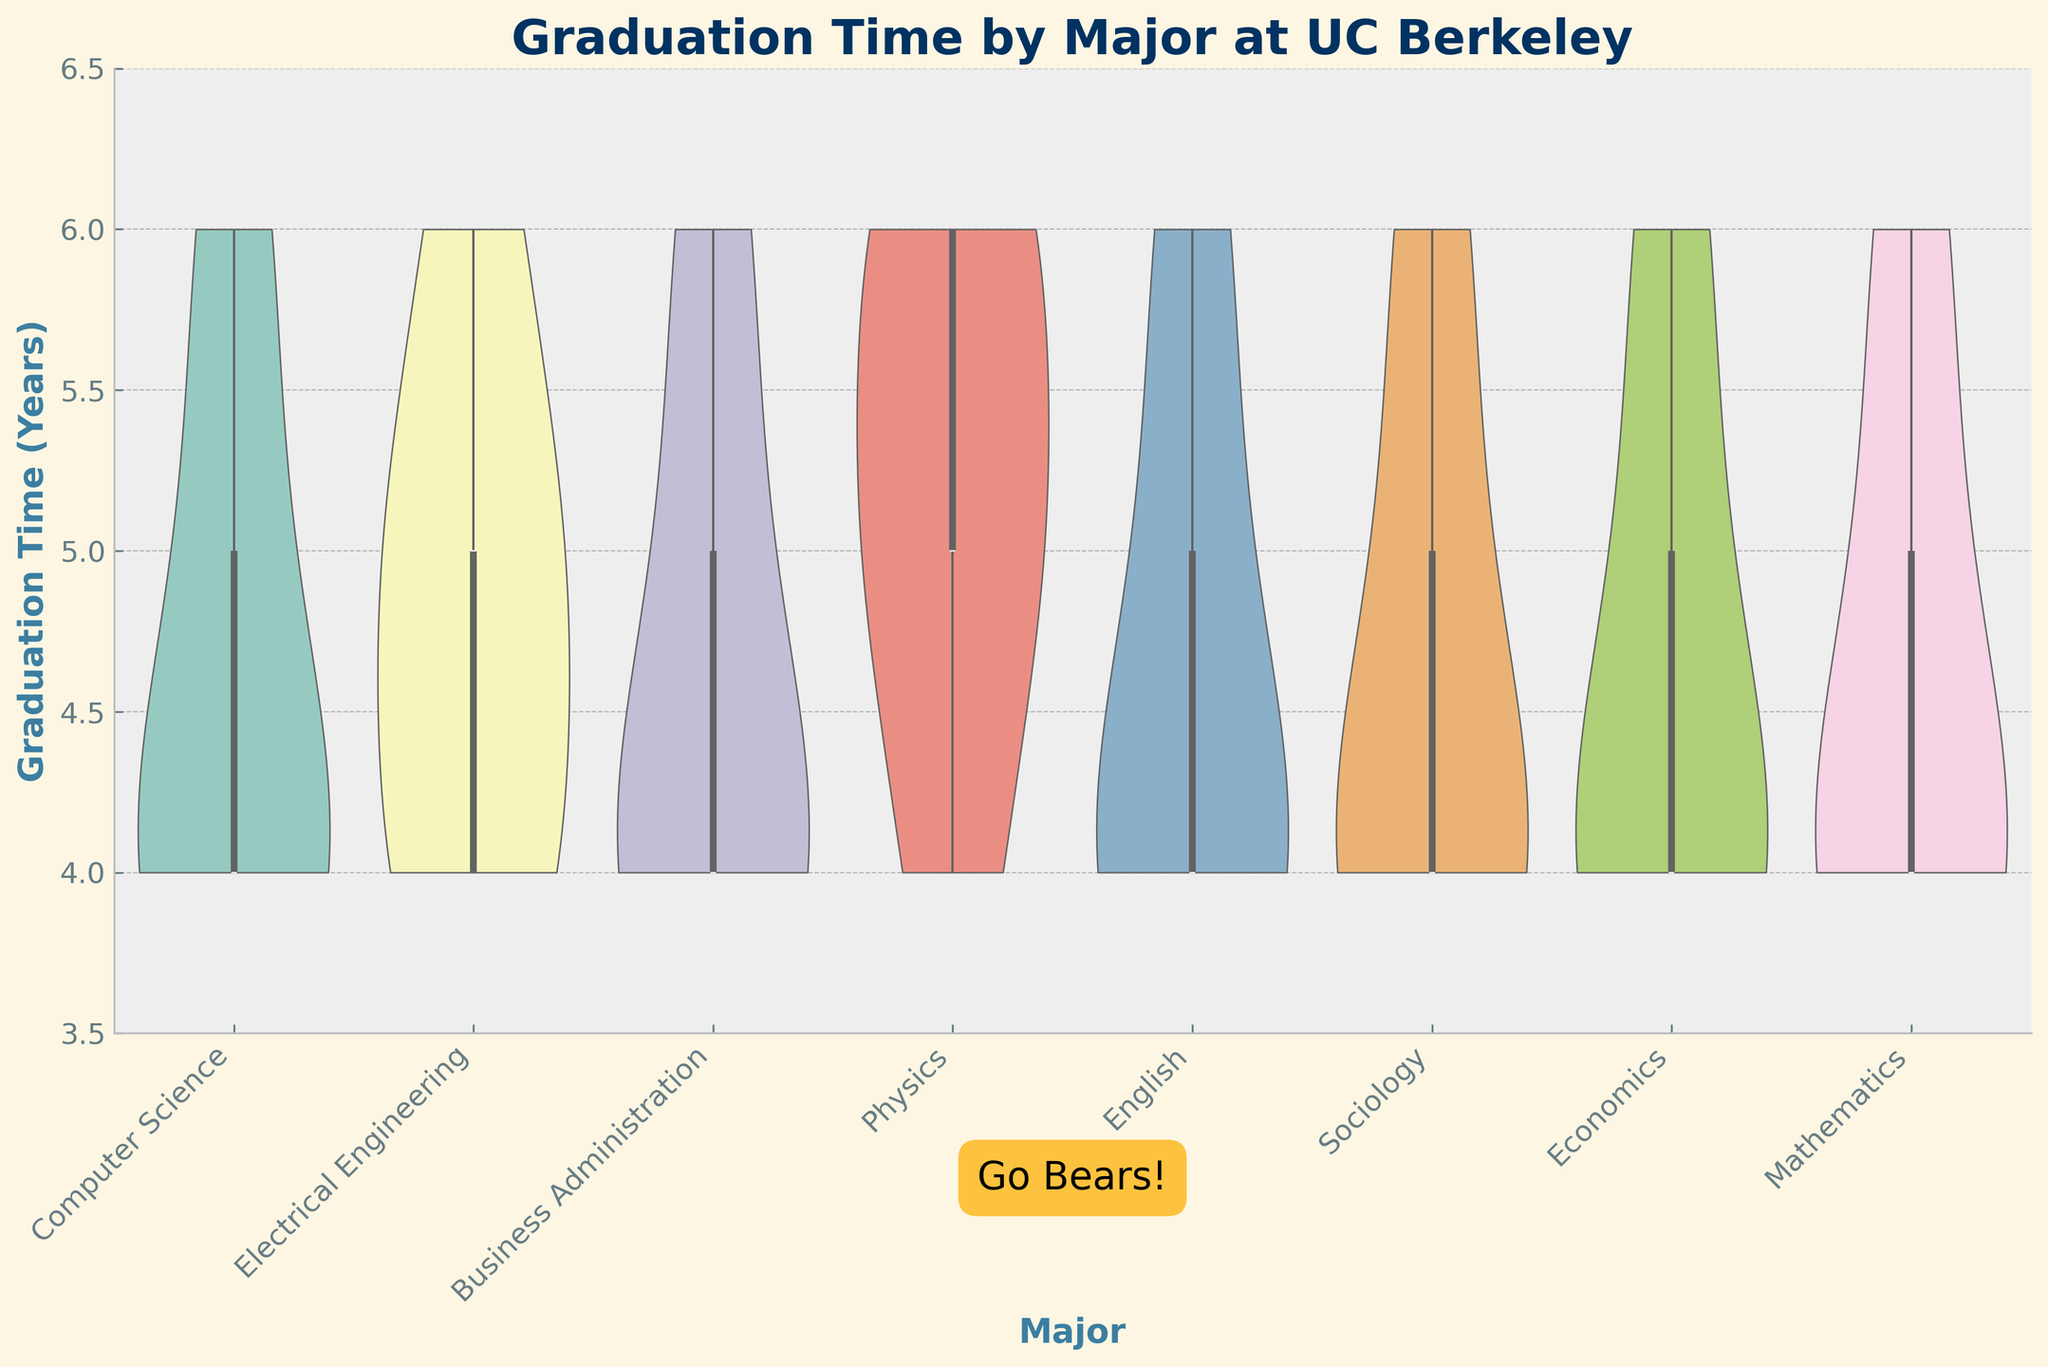How many majors are represented in the chart? Count the number of unique major labels on the x-axis.
Answer: 7 Which major has the highest median graduation time? Look for the median line (usually the thick middle line inside the box plot) that is the highest among all majors.
Answer: Physics Are there any majors where all students graduated in exactly 4 years? Check each violin plot to see if any major has all data points clustered at 4 years. None of the distributions should spread out from 4 years.
Answer: None What is the range of graduation times for Business Administration students? Identify the minimum and maximum graduation times for the Business Administration students by observing the extent of the violin plot for this major. The bottom of the violin represents the minimum (4 years) and the top represents the maximum (6 years).
Answer: 4-6 years Which major shows the most variability in graduation times? Determine which violin plot is the widest vertically (indicating a larger spread of graduation times).
Answer: Physics How does the median graduation time for Computer Science compare to Economics? Compare the positions of the median lines (thick middle line inside the box plot) for both Computer Science and Economics.
Answer: The median graduation times for both are at 4 years Which major has the least interquartile range (IQR) for graduation time? Identify the major with the most compressed (shortest) box in the box plot, representing the smallest IQR.
Answer: Sociology Do any majors have outliers, and if so, which ones? Look for any points outside the whiskers of the box plots that are distinctly separate from the rest of the data.
Answer: No apparent outliers On average, do STEM majors (like Computer Science, Electrical Engineering, Physics, Mathematics) take longer to graduate than non-STEM majors (like Business Administration, English, Sociology, Economics)? Estimate the central tendency (mean or median) of graduation times for each category and compare.
Answer: STEM majors seem to take longer on average Is there a standout major for the shortest average graduation time? Identify which violin plot shows the lowest overall graduation times consistently, focusing on the median and spread.
Answer: Computer Science 